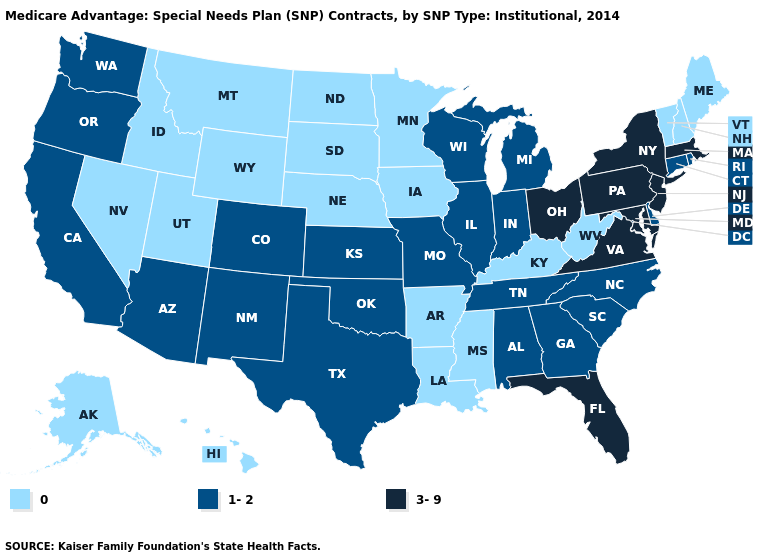Which states have the lowest value in the West?
Short answer required. Alaska, Hawaii, Idaho, Montana, Nevada, Utah, Wyoming. Name the states that have a value in the range 1-2?
Concise answer only. Alabama, Arizona, California, Colorado, Connecticut, Delaware, Georgia, Illinois, Indiana, Kansas, Michigan, Missouri, North Carolina, New Mexico, Oklahoma, Oregon, Rhode Island, South Carolina, Tennessee, Texas, Washington, Wisconsin. Name the states that have a value in the range 1-2?
Quick response, please. Alabama, Arizona, California, Colorado, Connecticut, Delaware, Georgia, Illinois, Indiana, Kansas, Michigan, Missouri, North Carolina, New Mexico, Oklahoma, Oregon, Rhode Island, South Carolina, Tennessee, Texas, Washington, Wisconsin. Does the first symbol in the legend represent the smallest category?
Quick response, please. Yes. Name the states that have a value in the range 0?
Be succinct. Alaska, Arkansas, Hawaii, Iowa, Idaho, Kentucky, Louisiana, Maine, Minnesota, Mississippi, Montana, North Dakota, Nebraska, New Hampshire, Nevada, South Dakota, Utah, Vermont, West Virginia, Wyoming. What is the value of Idaho?
Give a very brief answer. 0. Which states have the lowest value in the USA?
Short answer required. Alaska, Arkansas, Hawaii, Iowa, Idaho, Kentucky, Louisiana, Maine, Minnesota, Mississippi, Montana, North Dakota, Nebraska, New Hampshire, Nevada, South Dakota, Utah, Vermont, West Virginia, Wyoming. Name the states that have a value in the range 0?
Write a very short answer. Alaska, Arkansas, Hawaii, Iowa, Idaho, Kentucky, Louisiana, Maine, Minnesota, Mississippi, Montana, North Dakota, Nebraska, New Hampshire, Nevada, South Dakota, Utah, Vermont, West Virginia, Wyoming. What is the value of South Carolina?
Concise answer only. 1-2. Name the states that have a value in the range 1-2?
Give a very brief answer. Alabama, Arizona, California, Colorado, Connecticut, Delaware, Georgia, Illinois, Indiana, Kansas, Michigan, Missouri, North Carolina, New Mexico, Oklahoma, Oregon, Rhode Island, South Carolina, Tennessee, Texas, Washington, Wisconsin. Is the legend a continuous bar?
Quick response, please. No. Does the first symbol in the legend represent the smallest category?
Give a very brief answer. Yes. Does North Carolina have a higher value than Minnesota?
Short answer required. Yes. How many symbols are there in the legend?
Be succinct. 3. 